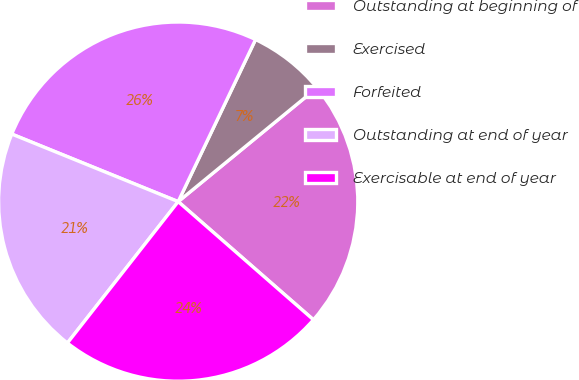<chart> <loc_0><loc_0><loc_500><loc_500><pie_chart><fcel>Outstanding at beginning of<fcel>Exercised<fcel>Forfeited<fcel>Outstanding at end of year<fcel>Exercisable at end of year<nl><fcel>22.36%<fcel>6.98%<fcel>25.95%<fcel>20.56%<fcel>24.15%<nl></chart> 